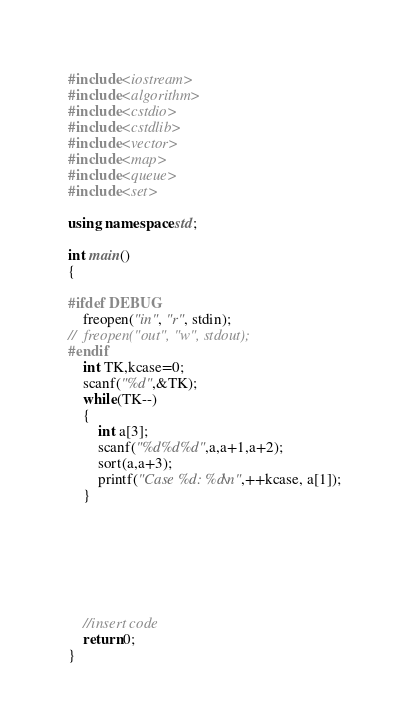Convert code to text. <code><loc_0><loc_0><loc_500><loc_500><_C++_>#include<iostream>
#include<algorithm>
#include<cstdio>
#include<cstdlib>
#include<vector>
#include<map>
#include<queue>
#include<set>

using namespace std;

int main()
{

#ifdef DEBUG
	freopen("in", "r", stdin);
//	freopen("out", "w", stdout);
#endif
	int TK,kcase=0;
	scanf("%d",&TK);
	while(TK--)
	{
		int a[3];
		scanf("%d%d%d",a,a+1,a+2);
		sort(a,a+3);
		printf("Case %d: %d\n",++kcase, a[1]);
	}

	




	
	//insert code
	return 0;
}
</code> 